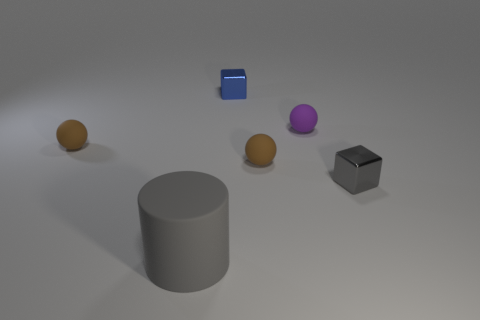Subtract all tiny brown balls. How many balls are left? 1 Subtract all gray blocks. How many blocks are left? 1 Add 4 small red spheres. How many objects exist? 10 Subtract 1 blocks. How many blocks are left? 1 Subtract 0 blue spheres. How many objects are left? 6 Subtract all blocks. How many objects are left? 4 Subtract all green blocks. Subtract all brown spheres. How many blocks are left? 2 Subtract all purple spheres. How many yellow cylinders are left? 0 Subtract all large gray rubber objects. Subtract all small brown rubber objects. How many objects are left? 3 Add 3 tiny gray blocks. How many tiny gray blocks are left? 4 